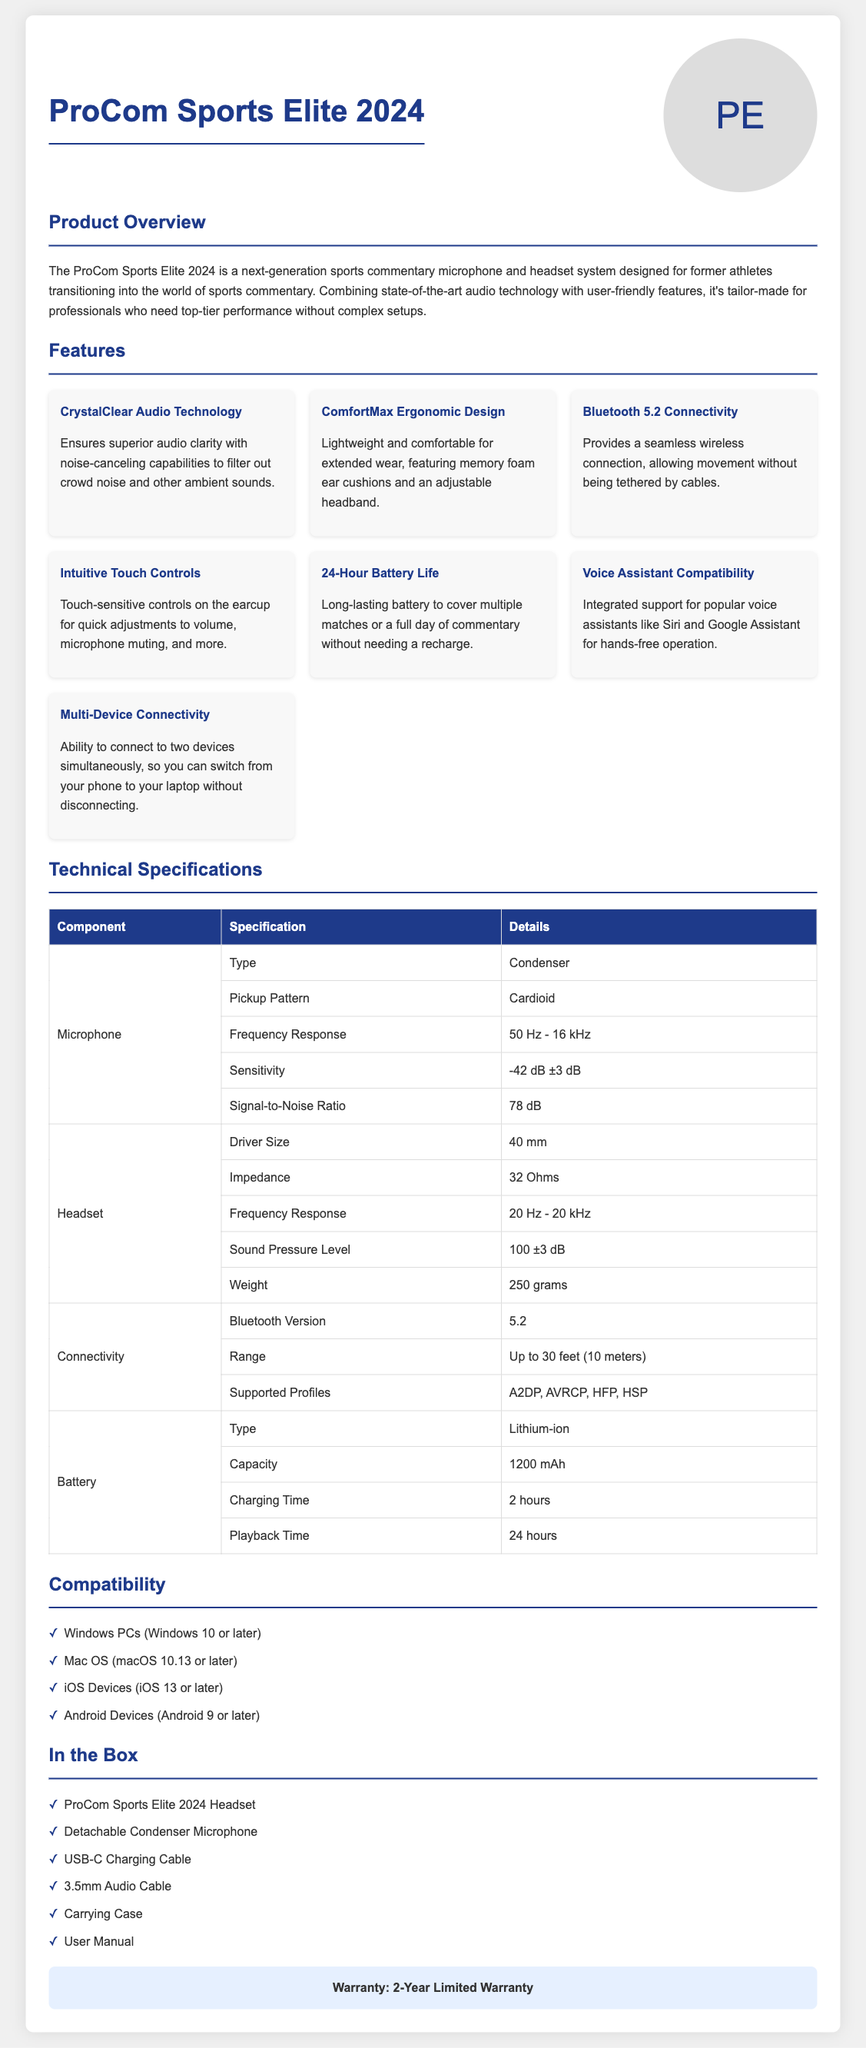what is the product name? The product name is prominently displayed at the top of the document.
Answer: ProCom Sports Elite 2024 what is the battery life? The document specifies the battery life of the headset system.
Answer: 24-Hour Battery Life how many grams does the headset weigh? The weight of the headset is listed in the technical specifications.
Answer: 250 grams what Bluetooth version does it use? The Bluetooth version is mentioned under the connectivity section.
Answer: 5.2 what is the frequency response of the microphone? The frequency response for the microphone component is detailed in the specifications table.
Answer: 50 Hz - 16 kHz which devices are compatible with the system? The compatibility section lists compatible operating systems and devices.
Answer: Windows PCs, Mac OS, iOS Devices, Android Devices what features support voice commands? The features section mentions a specific capability for voice control.
Answer: Voice Assistant Compatibility how much time is needed for charging? The charging time is specified in the technical specifications.
Answer: 2 hours how long is the warranty period? The warranty information is clearly stated at the end of the document.
Answer: 2-Year Limited Warranty 